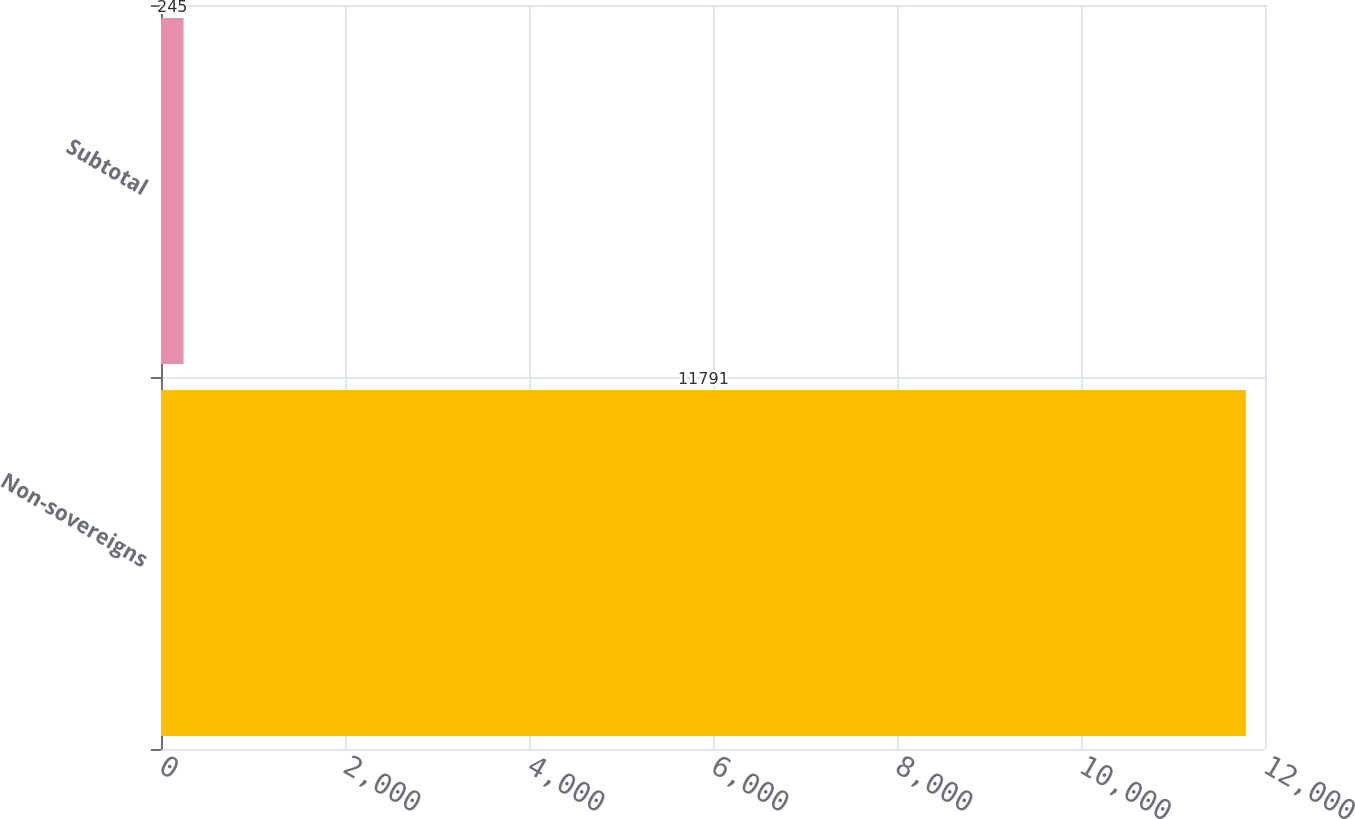<chart> <loc_0><loc_0><loc_500><loc_500><bar_chart><fcel>Non-sovereigns<fcel>Subtotal<nl><fcel>11791<fcel>245<nl></chart> 